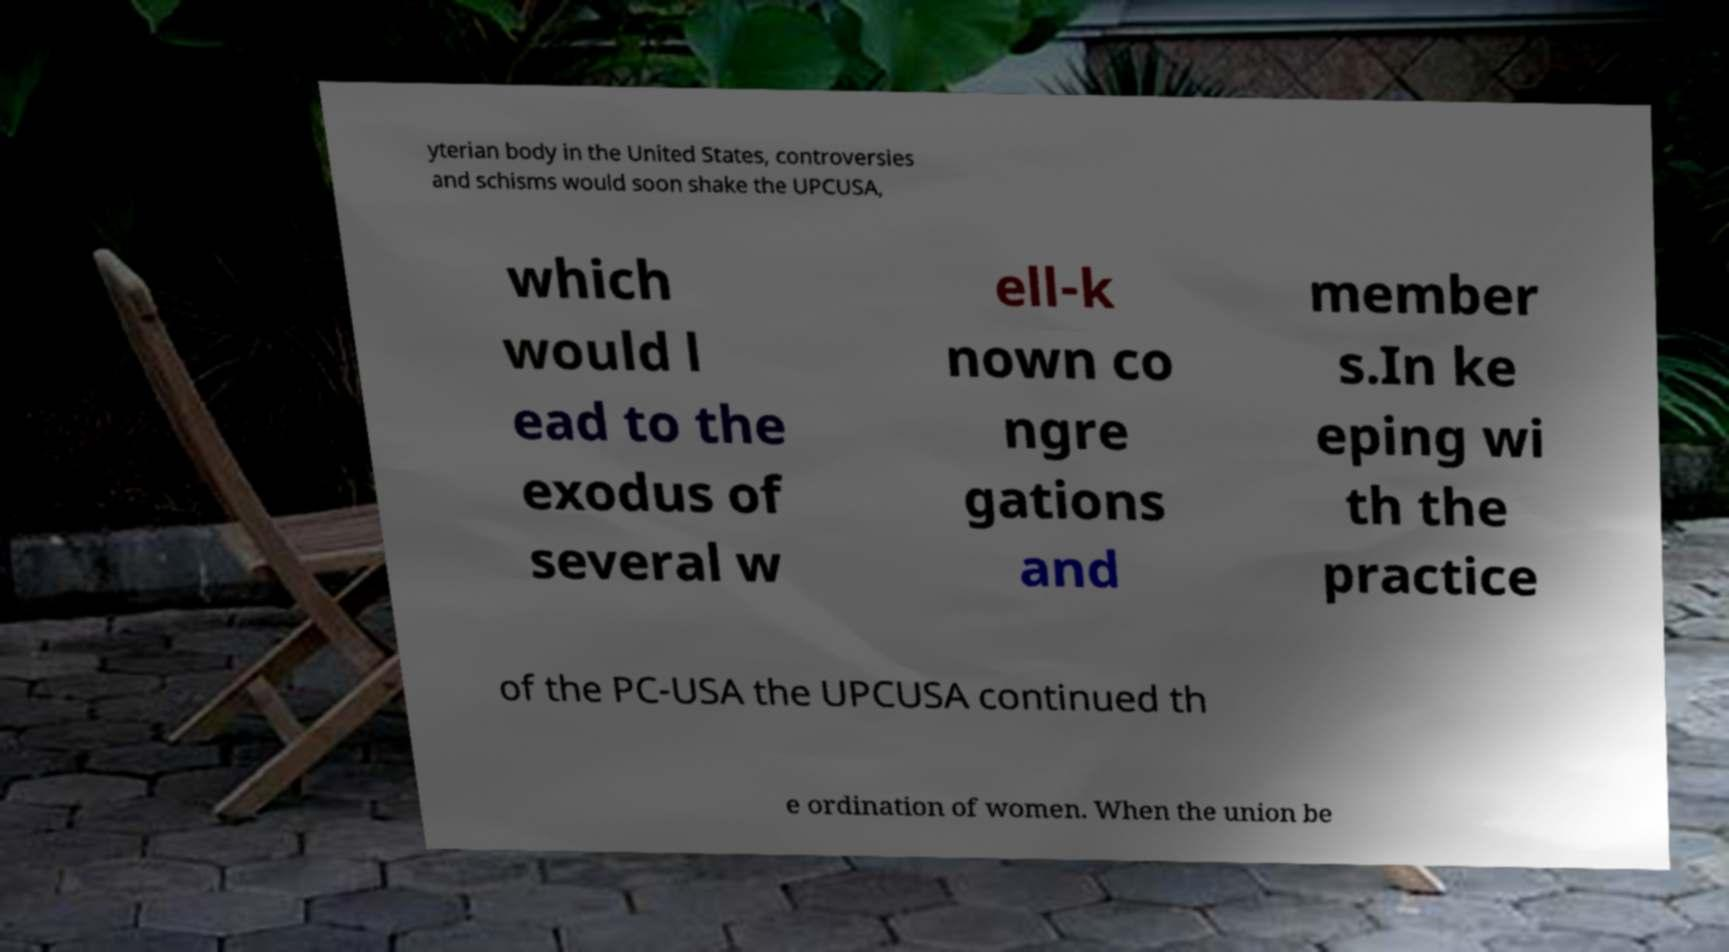I need the written content from this picture converted into text. Can you do that? yterian body in the United States, controversies and schisms would soon shake the UPCUSA, which would l ead to the exodus of several w ell-k nown co ngre gations and member s.In ke eping wi th the practice of the PC-USA the UPCUSA continued th e ordination of women. When the union be 